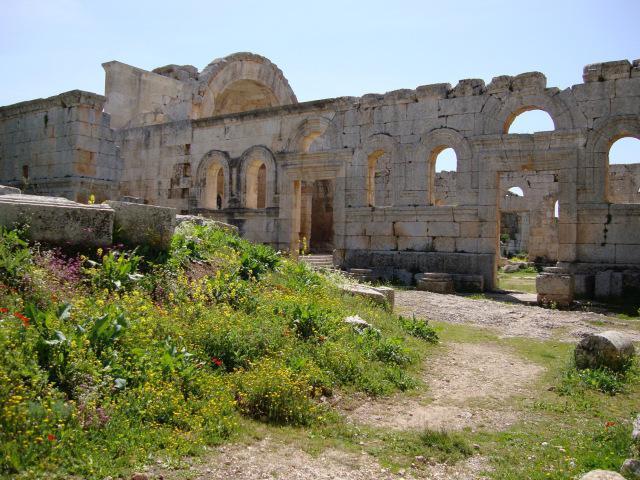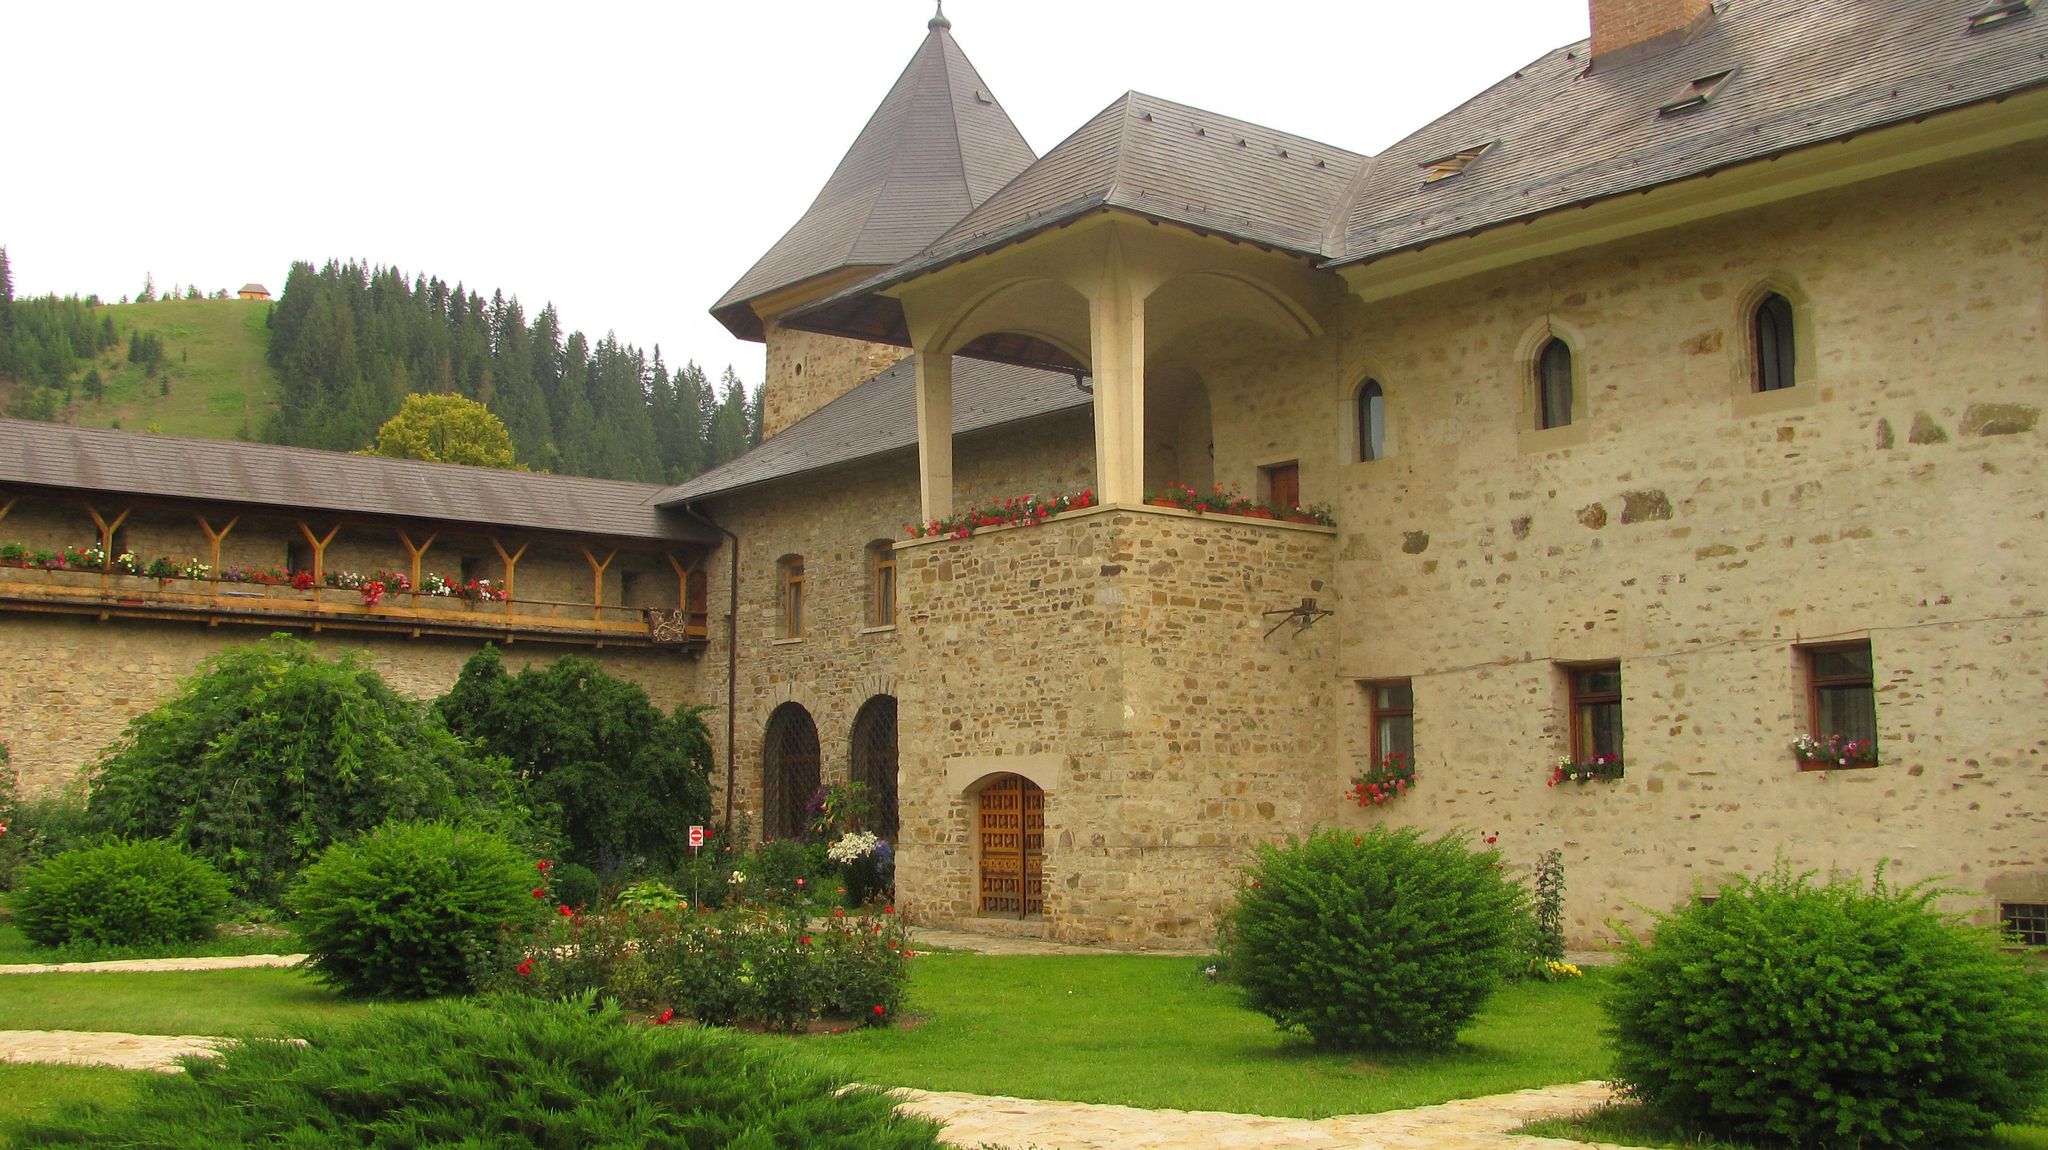The first image is the image on the left, the second image is the image on the right. Examine the images to the left and right. Is the description "One building is beige stone with arch elements and a landscaped lawn that includes shrubs." accurate? Answer yes or no. Yes. The first image is the image on the left, the second image is the image on the right. Evaluate the accuracy of this statement regarding the images: "There's a dirt path through the grass in the left image.". Is it true? Answer yes or no. Yes. 